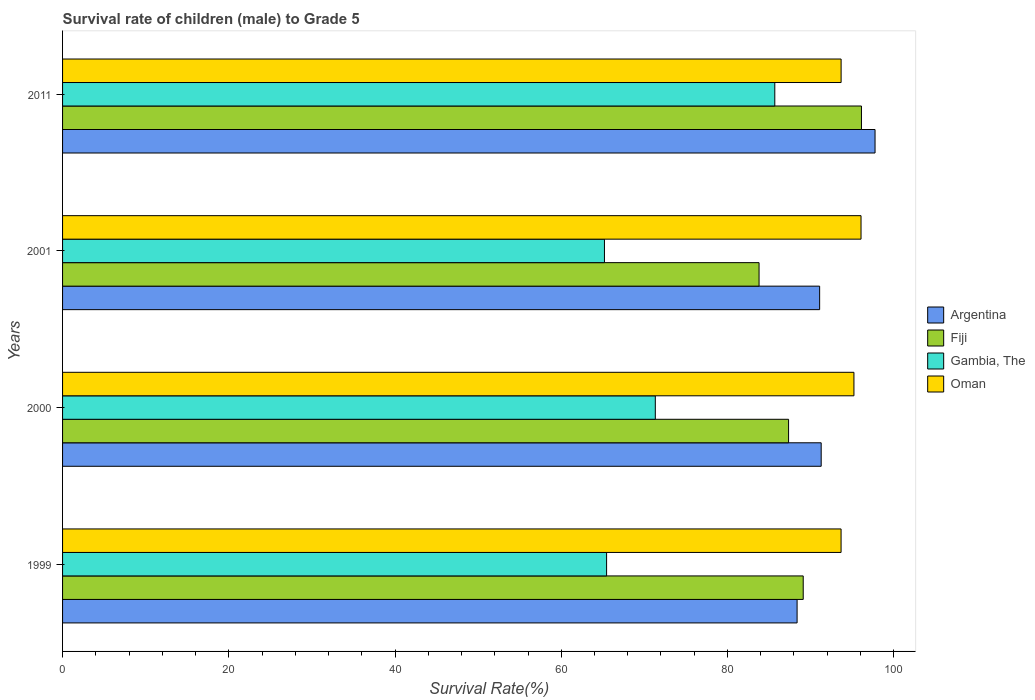How many different coloured bars are there?
Provide a succinct answer. 4. Are the number of bars per tick equal to the number of legend labels?
Ensure brevity in your answer.  Yes. How many bars are there on the 2nd tick from the top?
Your response must be concise. 4. How many bars are there on the 3rd tick from the bottom?
Your answer should be very brief. 4. What is the label of the 3rd group of bars from the top?
Your answer should be very brief. 2000. What is the survival rate of male children to grade 5 in Fiji in 2011?
Provide a succinct answer. 96.12. Across all years, what is the maximum survival rate of male children to grade 5 in Oman?
Keep it short and to the point. 96.07. Across all years, what is the minimum survival rate of male children to grade 5 in Oman?
Offer a terse response. 93.67. In which year was the survival rate of male children to grade 5 in Fiji maximum?
Your response must be concise. 2011. What is the total survival rate of male children to grade 5 in Gambia, The in the graph?
Offer a terse response. 287.66. What is the difference between the survival rate of male children to grade 5 in Argentina in 1999 and that in 2011?
Your answer should be very brief. -9.38. What is the difference between the survival rate of male children to grade 5 in Gambia, The in 2000 and the survival rate of male children to grade 5 in Oman in 2001?
Give a very brief answer. -24.75. What is the average survival rate of male children to grade 5 in Fiji per year?
Offer a very short reply. 89.1. In the year 1999, what is the difference between the survival rate of male children to grade 5 in Argentina and survival rate of male children to grade 5 in Fiji?
Keep it short and to the point. -0.74. What is the ratio of the survival rate of male children to grade 5 in Gambia, The in 2000 to that in 2011?
Make the answer very short. 0.83. What is the difference between the highest and the second highest survival rate of male children to grade 5 in Oman?
Offer a terse response. 0.85. What is the difference between the highest and the lowest survival rate of male children to grade 5 in Oman?
Give a very brief answer. 2.4. In how many years, is the survival rate of male children to grade 5 in Gambia, The greater than the average survival rate of male children to grade 5 in Gambia, The taken over all years?
Provide a short and direct response. 1. What does the 3rd bar from the bottom in 2011 represents?
Offer a terse response. Gambia, The. Is it the case that in every year, the sum of the survival rate of male children to grade 5 in Oman and survival rate of male children to grade 5 in Gambia, The is greater than the survival rate of male children to grade 5 in Argentina?
Ensure brevity in your answer.  Yes. How many bars are there?
Give a very brief answer. 16. Are all the bars in the graph horizontal?
Your response must be concise. Yes. How many years are there in the graph?
Make the answer very short. 4. What is the difference between two consecutive major ticks on the X-axis?
Ensure brevity in your answer.  20. Are the values on the major ticks of X-axis written in scientific E-notation?
Offer a terse response. No. Does the graph contain grids?
Keep it short and to the point. No. What is the title of the graph?
Give a very brief answer. Survival rate of children (male) to Grade 5. What is the label or title of the X-axis?
Provide a succinct answer. Survival Rate(%). What is the label or title of the Y-axis?
Your answer should be compact. Years. What is the Survival Rate(%) in Argentina in 1999?
Your answer should be compact. 88.38. What is the Survival Rate(%) in Fiji in 1999?
Your answer should be very brief. 89.11. What is the Survival Rate(%) of Gambia, The in 1999?
Offer a terse response. 65.46. What is the Survival Rate(%) in Oman in 1999?
Ensure brevity in your answer.  93.67. What is the Survival Rate(%) of Argentina in 2000?
Offer a terse response. 91.27. What is the Survival Rate(%) in Fiji in 2000?
Your answer should be very brief. 87.35. What is the Survival Rate(%) of Gambia, The in 2000?
Keep it short and to the point. 71.32. What is the Survival Rate(%) of Oman in 2000?
Keep it short and to the point. 95.22. What is the Survival Rate(%) of Argentina in 2001?
Keep it short and to the point. 91.09. What is the Survival Rate(%) in Fiji in 2001?
Offer a terse response. 83.8. What is the Survival Rate(%) in Gambia, The in 2001?
Your response must be concise. 65.2. What is the Survival Rate(%) in Oman in 2001?
Offer a very short reply. 96.07. What is the Survival Rate(%) in Argentina in 2011?
Your answer should be compact. 97.75. What is the Survival Rate(%) of Fiji in 2011?
Your answer should be very brief. 96.12. What is the Survival Rate(%) in Gambia, The in 2011?
Provide a short and direct response. 85.69. What is the Survival Rate(%) in Oman in 2011?
Ensure brevity in your answer.  93.67. Across all years, what is the maximum Survival Rate(%) of Argentina?
Provide a short and direct response. 97.75. Across all years, what is the maximum Survival Rate(%) in Fiji?
Make the answer very short. 96.12. Across all years, what is the maximum Survival Rate(%) of Gambia, The?
Your answer should be very brief. 85.69. Across all years, what is the maximum Survival Rate(%) of Oman?
Your answer should be very brief. 96.07. Across all years, what is the minimum Survival Rate(%) of Argentina?
Give a very brief answer. 88.38. Across all years, what is the minimum Survival Rate(%) of Fiji?
Your answer should be very brief. 83.8. Across all years, what is the minimum Survival Rate(%) of Gambia, The?
Your answer should be compact. 65.2. Across all years, what is the minimum Survival Rate(%) in Oman?
Offer a very short reply. 93.67. What is the total Survival Rate(%) of Argentina in the graph?
Provide a short and direct response. 368.49. What is the total Survival Rate(%) of Fiji in the graph?
Your response must be concise. 356.38. What is the total Survival Rate(%) of Gambia, The in the graph?
Provide a short and direct response. 287.66. What is the total Survival Rate(%) of Oman in the graph?
Keep it short and to the point. 378.62. What is the difference between the Survival Rate(%) in Argentina in 1999 and that in 2000?
Offer a terse response. -2.9. What is the difference between the Survival Rate(%) in Fiji in 1999 and that in 2000?
Give a very brief answer. 1.76. What is the difference between the Survival Rate(%) of Gambia, The in 1999 and that in 2000?
Your answer should be very brief. -5.86. What is the difference between the Survival Rate(%) of Oman in 1999 and that in 2000?
Your answer should be compact. -1.55. What is the difference between the Survival Rate(%) of Argentina in 1999 and that in 2001?
Your response must be concise. -2.71. What is the difference between the Survival Rate(%) in Fiji in 1999 and that in 2001?
Your answer should be compact. 5.31. What is the difference between the Survival Rate(%) of Gambia, The in 1999 and that in 2001?
Keep it short and to the point. 0.26. What is the difference between the Survival Rate(%) of Oman in 1999 and that in 2001?
Give a very brief answer. -2.4. What is the difference between the Survival Rate(%) of Argentina in 1999 and that in 2011?
Your answer should be very brief. -9.38. What is the difference between the Survival Rate(%) of Fiji in 1999 and that in 2011?
Offer a very short reply. -7.01. What is the difference between the Survival Rate(%) of Gambia, The in 1999 and that in 2011?
Your answer should be compact. -20.24. What is the difference between the Survival Rate(%) of Oman in 1999 and that in 2011?
Provide a succinct answer. -0. What is the difference between the Survival Rate(%) of Argentina in 2000 and that in 2001?
Give a very brief answer. 0.19. What is the difference between the Survival Rate(%) of Fiji in 2000 and that in 2001?
Ensure brevity in your answer.  3.55. What is the difference between the Survival Rate(%) of Gambia, The in 2000 and that in 2001?
Provide a succinct answer. 6.12. What is the difference between the Survival Rate(%) of Oman in 2000 and that in 2001?
Give a very brief answer. -0.85. What is the difference between the Survival Rate(%) of Argentina in 2000 and that in 2011?
Offer a terse response. -6.48. What is the difference between the Survival Rate(%) of Fiji in 2000 and that in 2011?
Offer a very short reply. -8.77. What is the difference between the Survival Rate(%) of Gambia, The in 2000 and that in 2011?
Offer a terse response. -14.38. What is the difference between the Survival Rate(%) in Oman in 2000 and that in 2011?
Give a very brief answer. 1.54. What is the difference between the Survival Rate(%) of Argentina in 2001 and that in 2011?
Keep it short and to the point. -6.67. What is the difference between the Survival Rate(%) in Fiji in 2001 and that in 2011?
Your response must be concise. -12.32. What is the difference between the Survival Rate(%) in Gambia, The in 2001 and that in 2011?
Your answer should be very brief. -20.5. What is the difference between the Survival Rate(%) in Oman in 2001 and that in 2011?
Your answer should be very brief. 2.4. What is the difference between the Survival Rate(%) of Argentina in 1999 and the Survival Rate(%) of Fiji in 2000?
Your response must be concise. 1.03. What is the difference between the Survival Rate(%) in Argentina in 1999 and the Survival Rate(%) in Gambia, The in 2000?
Provide a short and direct response. 17.06. What is the difference between the Survival Rate(%) in Argentina in 1999 and the Survival Rate(%) in Oman in 2000?
Provide a short and direct response. -6.84. What is the difference between the Survival Rate(%) of Fiji in 1999 and the Survival Rate(%) of Gambia, The in 2000?
Your response must be concise. 17.8. What is the difference between the Survival Rate(%) of Fiji in 1999 and the Survival Rate(%) of Oman in 2000?
Your answer should be compact. -6.1. What is the difference between the Survival Rate(%) in Gambia, The in 1999 and the Survival Rate(%) in Oman in 2000?
Offer a very short reply. -29.76. What is the difference between the Survival Rate(%) of Argentina in 1999 and the Survival Rate(%) of Fiji in 2001?
Provide a succinct answer. 4.58. What is the difference between the Survival Rate(%) of Argentina in 1999 and the Survival Rate(%) of Gambia, The in 2001?
Make the answer very short. 23.18. What is the difference between the Survival Rate(%) in Argentina in 1999 and the Survival Rate(%) in Oman in 2001?
Your answer should be very brief. -7.69. What is the difference between the Survival Rate(%) of Fiji in 1999 and the Survival Rate(%) of Gambia, The in 2001?
Give a very brief answer. 23.92. What is the difference between the Survival Rate(%) of Fiji in 1999 and the Survival Rate(%) of Oman in 2001?
Your response must be concise. -6.95. What is the difference between the Survival Rate(%) of Gambia, The in 1999 and the Survival Rate(%) of Oman in 2001?
Keep it short and to the point. -30.61. What is the difference between the Survival Rate(%) of Argentina in 1999 and the Survival Rate(%) of Fiji in 2011?
Your answer should be compact. -7.74. What is the difference between the Survival Rate(%) of Argentina in 1999 and the Survival Rate(%) of Gambia, The in 2011?
Provide a succinct answer. 2.68. What is the difference between the Survival Rate(%) in Argentina in 1999 and the Survival Rate(%) in Oman in 2011?
Provide a succinct answer. -5.3. What is the difference between the Survival Rate(%) of Fiji in 1999 and the Survival Rate(%) of Gambia, The in 2011?
Your answer should be compact. 3.42. What is the difference between the Survival Rate(%) in Fiji in 1999 and the Survival Rate(%) in Oman in 2011?
Your answer should be very brief. -4.56. What is the difference between the Survival Rate(%) of Gambia, The in 1999 and the Survival Rate(%) of Oman in 2011?
Provide a succinct answer. -28.22. What is the difference between the Survival Rate(%) in Argentina in 2000 and the Survival Rate(%) in Fiji in 2001?
Provide a succinct answer. 7.47. What is the difference between the Survival Rate(%) of Argentina in 2000 and the Survival Rate(%) of Gambia, The in 2001?
Provide a short and direct response. 26.08. What is the difference between the Survival Rate(%) of Argentina in 2000 and the Survival Rate(%) of Oman in 2001?
Your answer should be very brief. -4.79. What is the difference between the Survival Rate(%) of Fiji in 2000 and the Survival Rate(%) of Gambia, The in 2001?
Provide a succinct answer. 22.15. What is the difference between the Survival Rate(%) in Fiji in 2000 and the Survival Rate(%) in Oman in 2001?
Your answer should be compact. -8.72. What is the difference between the Survival Rate(%) of Gambia, The in 2000 and the Survival Rate(%) of Oman in 2001?
Ensure brevity in your answer.  -24.75. What is the difference between the Survival Rate(%) of Argentina in 2000 and the Survival Rate(%) of Fiji in 2011?
Give a very brief answer. -4.84. What is the difference between the Survival Rate(%) of Argentina in 2000 and the Survival Rate(%) of Gambia, The in 2011?
Offer a very short reply. 5.58. What is the difference between the Survival Rate(%) of Argentina in 2000 and the Survival Rate(%) of Oman in 2011?
Give a very brief answer. -2.4. What is the difference between the Survival Rate(%) in Fiji in 2000 and the Survival Rate(%) in Gambia, The in 2011?
Provide a succinct answer. 1.66. What is the difference between the Survival Rate(%) of Fiji in 2000 and the Survival Rate(%) of Oman in 2011?
Your answer should be very brief. -6.32. What is the difference between the Survival Rate(%) in Gambia, The in 2000 and the Survival Rate(%) in Oman in 2011?
Ensure brevity in your answer.  -22.35. What is the difference between the Survival Rate(%) in Argentina in 2001 and the Survival Rate(%) in Fiji in 2011?
Provide a short and direct response. -5.03. What is the difference between the Survival Rate(%) in Argentina in 2001 and the Survival Rate(%) in Gambia, The in 2011?
Your answer should be compact. 5.39. What is the difference between the Survival Rate(%) of Argentina in 2001 and the Survival Rate(%) of Oman in 2011?
Provide a succinct answer. -2.58. What is the difference between the Survival Rate(%) in Fiji in 2001 and the Survival Rate(%) in Gambia, The in 2011?
Your answer should be compact. -1.89. What is the difference between the Survival Rate(%) in Fiji in 2001 and the Survival Rate(%) in Oman in 2011?
Make the answer very short. -9.87. What is the difference between the Survival Rate(%) of Gambia, The in 2001 and the Survival Rate(%) of Oman in 2011?
Offer a very short reply. -28.47. What is the average Survival Rate(%) of Argentina per year?
Your answer should be very brief. 92.12. What is the average Survival Rate(%) in Fiji per year?
Give a very brief answer. 89.1. What is the average Survival Rate(%) in Gambia, The per year?
Offer a terse response. 71.92. What is the average Survival Rate(%) in Oman per year?
Your answer should be compact. 94.66. In the year 1999, what is the difference between the Survival Rate(%) in Argentina and Survival Rate(%) in Fiji?
Make the answer very short. -0.74. In the year 1999, what is the difference between the Survival Rate(%) of Argentina and Survival Rate(%) of Gambia, The?
Make the answer very short. 22.92. In the year 1999, what is the difference between the Survival Rate(%) of Argentina and Survival Rate(%) of Oman?
Make the answer very short. -5.29. In the year 1999, what is the difference between the Survival Rate(%) in Fiji and Survival Rate(%) in Gambia, The?
Give a very brief answer. 23.66. In the year 1999, what is the difference between the Survival Rate(%) of Fiji and Survival Rate(%) of Oman?
Your answer should be very brief. -4.55. In the year 1999, what is the difference between the Survival Rate(%) in Gambia, The and Survival Rate(%) in Oman?
Your answer should be compact. -28.21. In the year 2000, what is the difference between the Survival Rate(%) of Argentina and Survival Rate(%) of Fiji?
Ensure brevity in your answer.  3.92. In the year 2000, what is the difference between the Survival Rate(%) of Argentina and Survival Rate(%) of Gambia, The?
Offer a terse response. 19.96. In the year 2000, what is the difference between the Survival Rate(%) in Argentina and Survival Rate(%) in Oman?
Provide a short and direct response. -3.94. In the year 2000, what is the difference between the Survival Rate(%) in Fiji and Survival Rate(%) in Gambia, The?
Make the answer very short. 16.03. In the year 2000, what is the difference between the Survival Rate(%) of Fiji and Survival Rate(%) of Oman?
Make the answer very short. -7.87. In the year 2000, what is the difference between the Survival Rate(%) of Gambia, The and Survival Rate(%) of Oman?
Your answer should be compact. -23.9. In the year 2001, what is the difference between the Survival Rate(%) of Argentina and Survival Rate(%) of Fiji?
Keep it short and to the point. 7.29. In the year 2001, what is the difference between the Survival Rate(%) in Argentina and Survival Rate(%) in Gambia, The?
Provide a short and direct response. 25.89. In the year 2001, what is the difference between the Survival Rate(%) in Argentina and Survival Rate(%) in Oman?
Make the answer very short. -4.98. In the year 2001, what is the difference between the Survival Rate(%) in Fiji and Survival Rate(%) in Gambia, The?
Offer a terse response. 18.6. In the year 2001, what is the difference between the Survival Rate(%) in Fiji and Survival Rate(%) in Oman?
Give a very brief answer. -12.27. In the year 2001, what is the difference between the Survival Rate(%) of Gambia, The and Survival Rate(%) of Oman?
Keep it short and to the point. -30.87. In the year 2011, what is the difference between the Survival Rate(%) in Argentina and Survival Rate(%) in Fiji?
Ensure brevity in your answer.  1.64. In the year 2011, what is the difference between the Survival Rate(%) in Argentina and Survival Rate(%) in Gambia, The?
Make the answer very short. 12.06. In the year 2011, what is the difference between the Survival Rate(%) of Argentina and Survival Rate(%) of Oman?
Ensure brevity in your answer.  4.08. In the year 2011, what is the difference between the Survival Rate(%) of Fiji and Survival Rate(%) of Gambia, The?
Your answer should be compact. 10.43. In the year 2011, what is the difference between the Survival Rate(%) in Fiji and Survival Rate(%) in Oman?
Provide a succinct answer. 2.45. In the year 2011, what is the difference between the Survival Rate(%) of Gambia, The and Survival Rate(%) of Oman?
Keep it short and to the point. -7.98. What is the ratio of the Survival Rate(%) in Argentina in 1999 to that in 2000?
Offer a terse response. 0.97. What is the ratio of the Survival Rate(%) in Fiji in 1999 to that in 2000?
Your answer should be very brief. 1.02. What is the ratio of the Survival Rate(%) in Gambia, The in 1999 to that in 2000?
Give a very brief answer. 0.92. What is the ratio of the Survival Rate(%) in Oman in 1999 to that in 2000?
Ensure brevity in your answer.  0.98. What is the ratio of the Survival Rate(%) in Argentina in 1999 to that in 2001?
Offer a very short reply. 0.97. What is the ratio of the Survival Rate(%) of Fiji in 1999 to that in 2001?
Offer a terse response. 1.06. What is the ratio of the Survival Rate(%) of Oman in 1999 to that in 2001?
Offer a terse response. 0.97. What is the ratio of the Survival Rate(%) in Argentina in 1999 to that in 2011?
Offer a very short reply. 0.9. What is the ratio of the Survival Rate(%) in Fiji in 1999 to that in 2011?
Your answer should be very brief. 0.93. What is the ratio of the Survival Rate(%) in Gambia, The in 1999 to that in 2011?
Offer a very short reply. 0.76. What is the ratio of the Survival Rate(%) of Oman in 1999 to that in 2011?
Provide a short and direct response. 1. What is the ratio of the Survival Rate(%) in Fiji in 2000 to that in 2001?
Provide a short and direct response. 1.04. What is the ratio of the Survival Rate(%) of Gambia, The in 2000 to that in 2001?
Keep it short and to the point. 1.09. What is the ratio of the Survival Rate(%) in Oman in 2000 to that in 2001?
Keep it short and to the point. 0.99. What is the ratio of the Survival Rate(%) of Argentina in 2000 to that in 2011?
Your answer should be very brief. 0.93. What is the ratio of the Survival Rate(%) in Fiji in 2000 to that in 2011?
Your answer should be compact. 0.91. What is the ratio of the Survival Rate(%) in Gambia, The in 2000 to that in 2011?
Provide a succinct answer. 0.83. What is the ratio of the Survival Rate(%) of Oman in 2000 to that in 2011?
Your answer should be very brief. 1.02. What is the ratio of the Survival Rate(%) in Argentina in 2001 to that in 2011?
Offer a terse response. 0.93. What is the ratio of the Survival Rate(%) of Fiji in 2001 to that in 2011?
Ensure brevity in your answer.  0.87. What is the ratio of the Survival Rate(%) of Gambia, The in 2001 to that in 2011?
Make the answer very short. 0.76. What is the ratio of the Survival Rate(%) in Oman in 2001 to that in 2011?
Ensure brevity in your answer.  1.03. What is the difference between the highest and the second highest Survival Rate(%) of Argentina?
Provide a short and direct response. 6.48. What is the difference between the highest and the second highest Survival Rate(%) in Fiji?
Keep it short and to the point. 7.01. What is the difference between the highest and the second highest Survival Rate(%) in Gambia, The?
Provide a succinct answer. 14.38. What is the difference between the highest and the second highest Survival Rate(%) in Oman?
Offer a terse response. 0.85. What is the difference between the highest and the lowest Survival Rate(%) of Argentina?
Offer a terse response. 9.38. What is the difference between the highest and the lowest Survival Rate(%) of Fiji?
Your answer should be very brief. 12.32. What is the difference between the highest and the lowest Survival Rate(%) in Gambia, The?
Make the answer very short. 20.5. What is the difference between the highest and the lowest Survival Rate(%) in Oman?
Give a very brief answer. 2.4. 